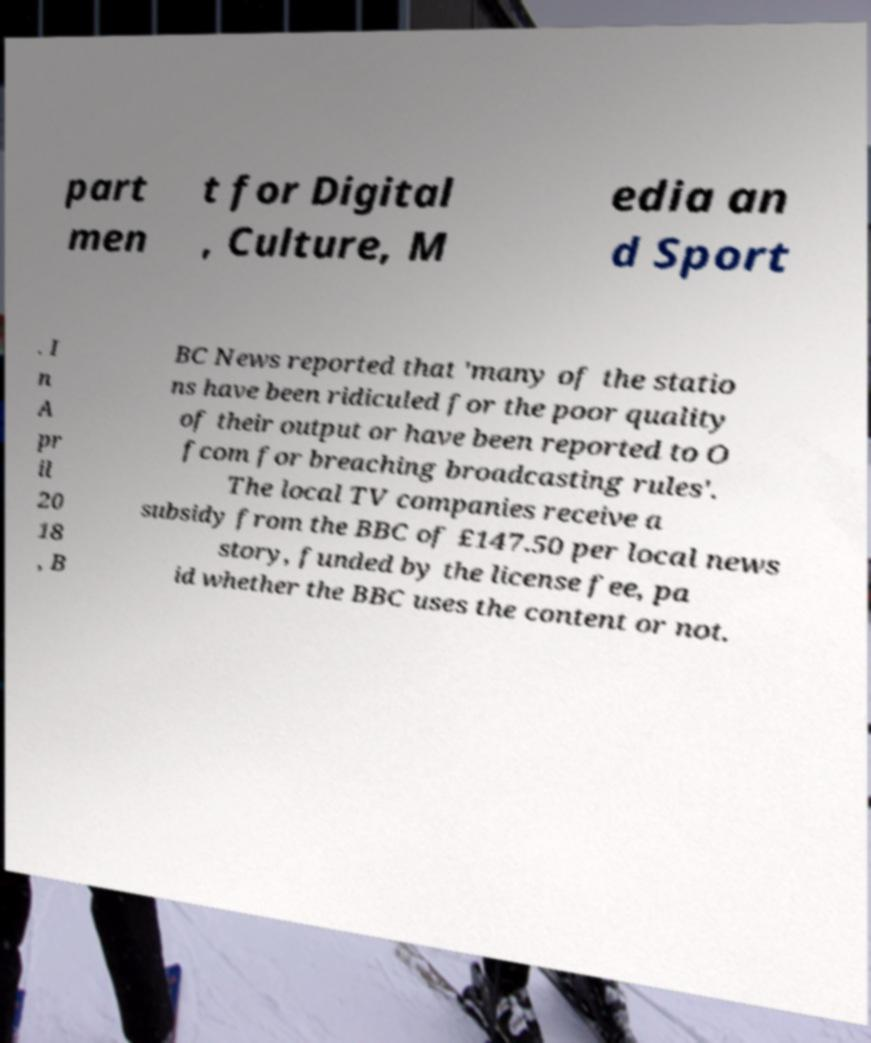Can you read and provide the text displayed in the image?This photo seems to have some interesting text. Can you extract and type it out for me? part men t for Digital , Culture, M edia an d Sport . I n A pr il 20 18 , B BC News reported that 'many of the statio ns have been ridiculed for the poor quality of their output or have been reported to O fcom for breaching broadcasting rules'. The local TV companies receive a subsidy from the BBC of £147.50 per local news story, funded by the license fee, pa id whether the BBC uses the content or not. 